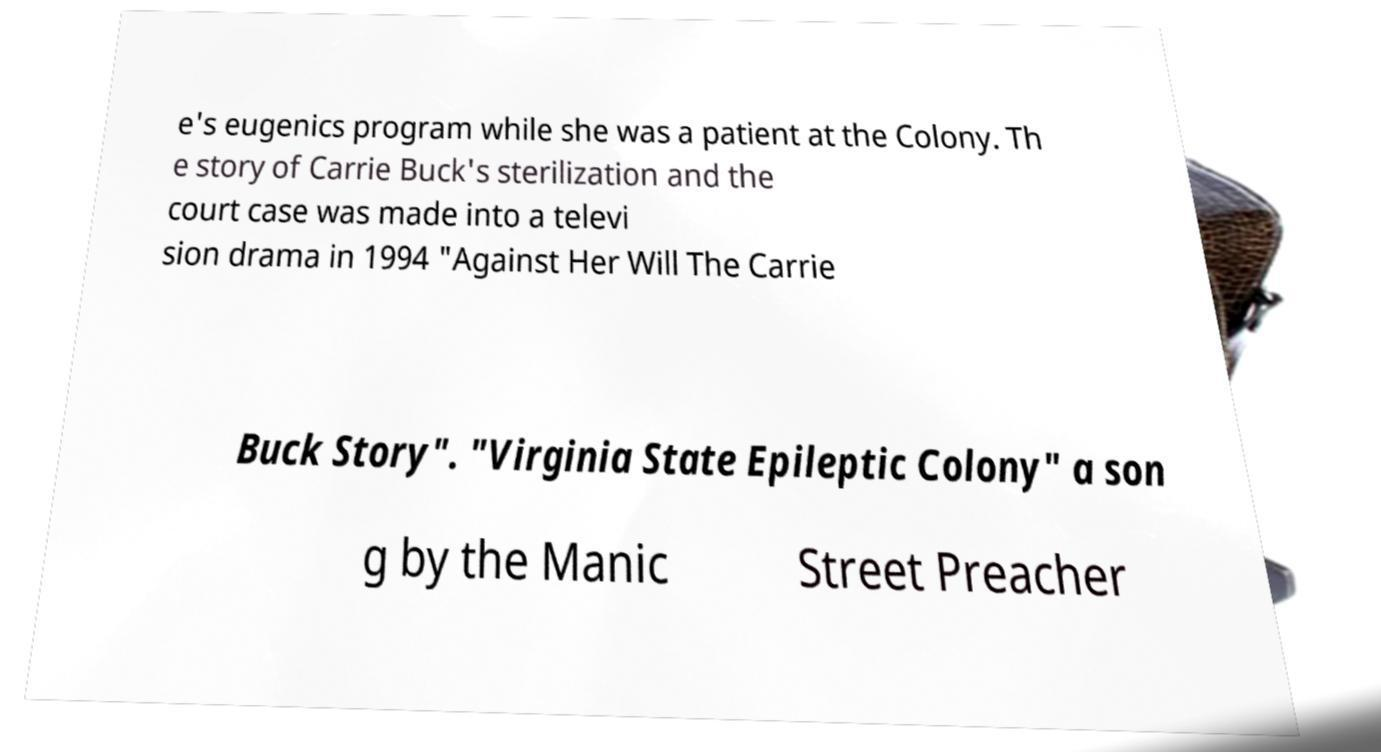Could you extract and type out the text from this image? e's eugenics program while she was a patient at the Colony. Th e story of Carrie Buck's sterilization and the court case was made into a televi sion drama in 1994 "Against Her Will The Carrie Buck Story". "Virginia State Epileptic Colony" a son g by the Manic Street Preacher 